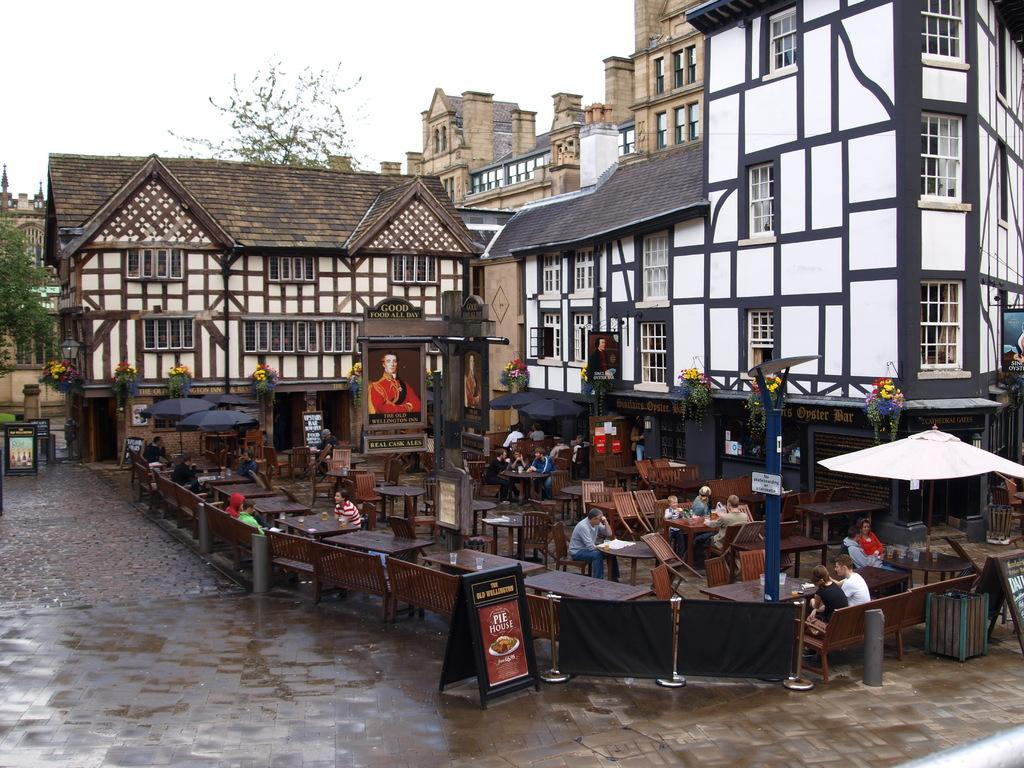What is located in the center of the image? There are buildings in the center of the image. What type of furniture can be seen in the image? There are chairs and tables in the image. What can be seen in the background of the image? There is a tree in the background of the image. What is at the bottom of the image? There is a road at the bottom of the image. Can you see any salt on the tables in the image? There is no salt visible on the tables in the image. Is there any blood visible on the chairs in the image? There is no blood visible on the chairs in the image. 